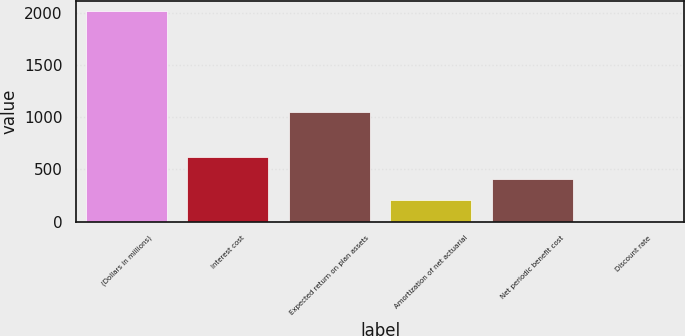<chart> <loc_0><loc_0><loc_500><loc_500><bar_chart><fcel>(Dollars in millions)<fcel>Interest cost<fcel>Expected return on plan assets<fcel>Amortization of net actuarial<fcel>Net periodic benefit cost<fcel>Discount rate<nl><fcel>2015<fcel>621<fcel>1045<fcel>205.21<fcel>406.3<fcel>4.12<nl></chart> 